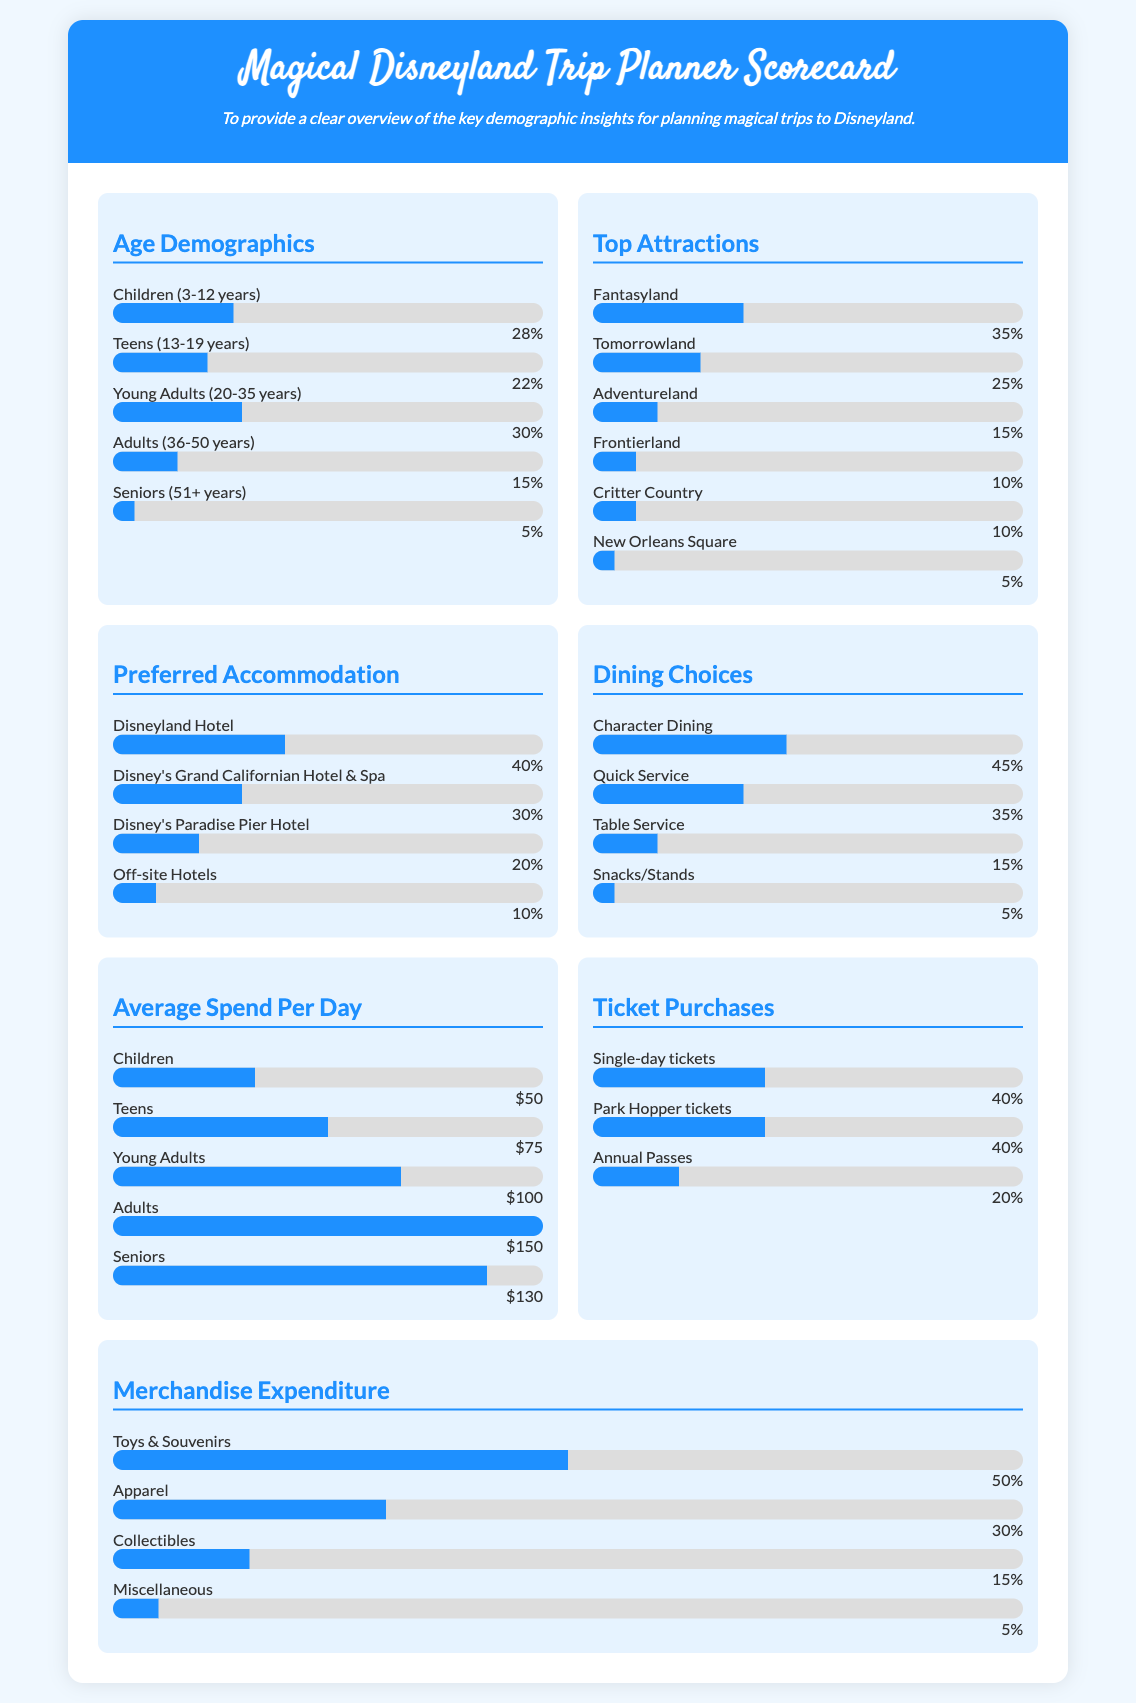What percentage of visitors are Children (3-12 years)? The document states that Children (3-12 years) comprise 28% of the visitors.
Answer: 28% What is the most preferred accommodation option? The scorecard shows that Disneyland Hotel is preferred by 40% of visitors, making it the top choice.
Answer: Disneyland Hotel How much do Young Adults (20-35 years) spend on average per day? According to the data, Young Adults spend an average of $100 per day.
Answer: $100 What are the top two attractions by percentage? Fantasyland and Tomorrowland have the highest percentages at 35% and 25%, respectively.
Answer: Fantasyland and Tomorrowland What percentage of tickets purchased are Annual Passes? The document indicates that 20% of tickets sold are Annual Passes.
Answer: 20% How many visitors prefer Character Dining? The data shows that 45% of visitors prefer Character Dining for their dining choices.
Answer: 45% What is the percentage of seniors (51+ years) among visitors? The document lists seniors (51+ years) at 5% of the total visitors.
Answer: 5% What is the average spend per day for Adults (36-50 years)? Adults spend on average $150 per day, according to the scorecard.
Answer: $150 